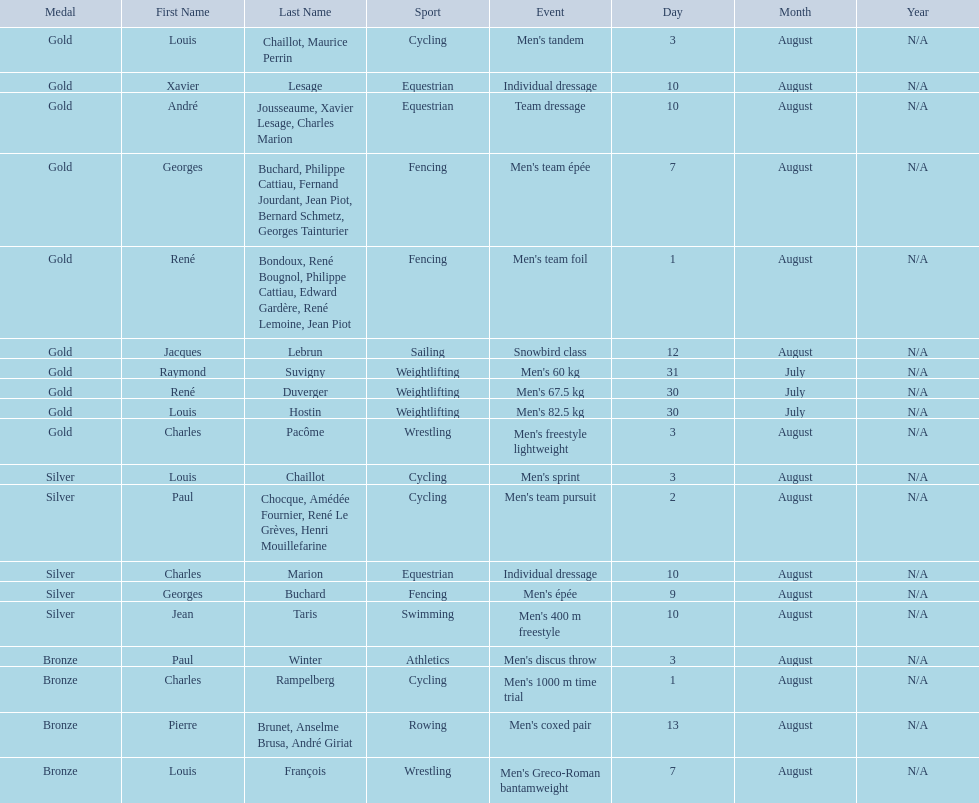Was there more gold medals won than silver? Yes. 